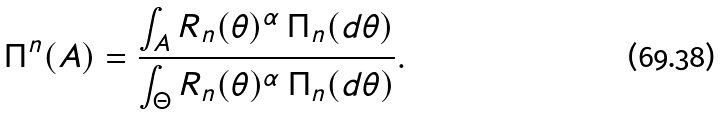<formula> <loc_0><loc_0><loc_500><loc_500>\Pi ^ { n } ( A ) = \frac { \int _ { A } R _ { n } ( \theta ) ^ { \alpha } \, \Pi _ { n } ( d \theta ) } { \int _ { \Theta } R _ { n } ( \theta ) ^ { \alpha } \, \Pi _ { n } ( d \theta ) } .</formula> 